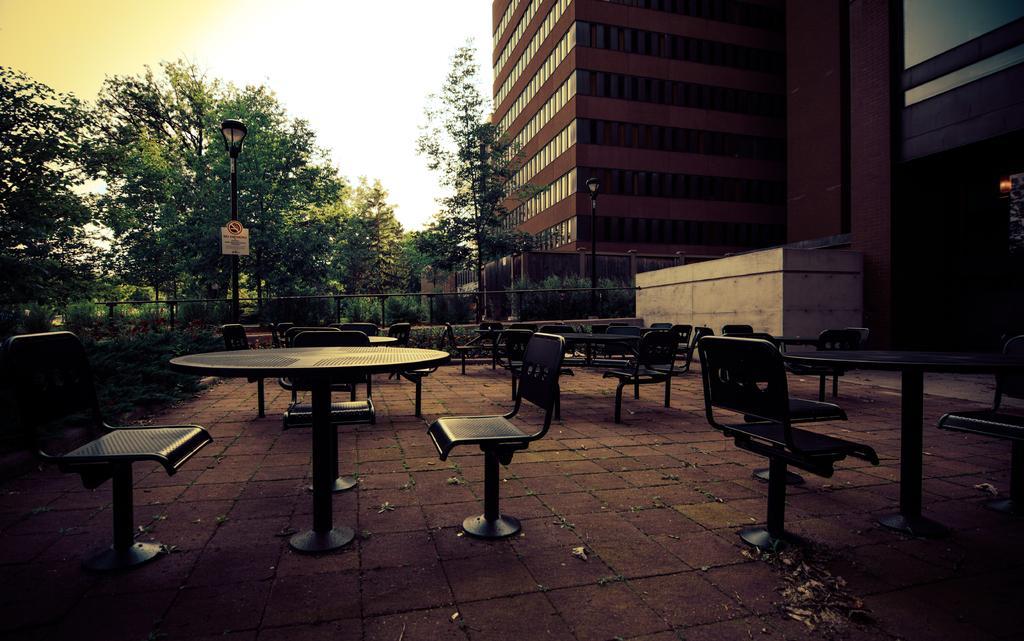Could you give a brief overview of what you see in this image? On the back there is big building and there are many tree over here and there are also many chair. 